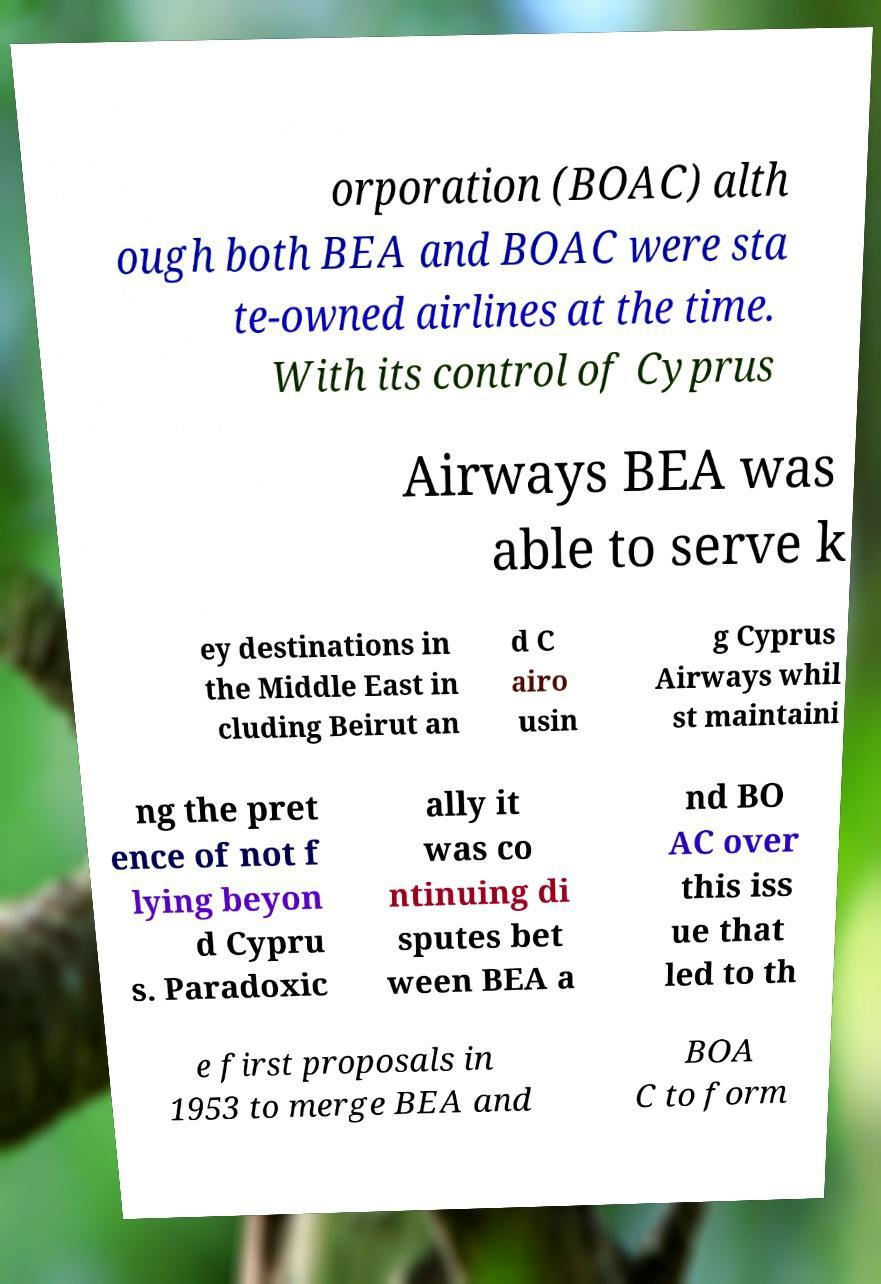Could you extract and type out the text from this image? orporation (BOAC) alth ough both BEA and BOAC were sta te-owned airlines at the time. With its control of Cyprus Airways BEA was able to serve k ey destinations in the Middle East in cluding Beirut an d C airo usin g Cyprus Airways whil st maintaini ng the pret ence of not f lying beyon d Cypru s. Paradoxic ally it was co ntinuing di sputes bet ween BEA a nd BO AC over this iss ue that led to th e first proposals in 1953 to merge BEA and BOA C to form 